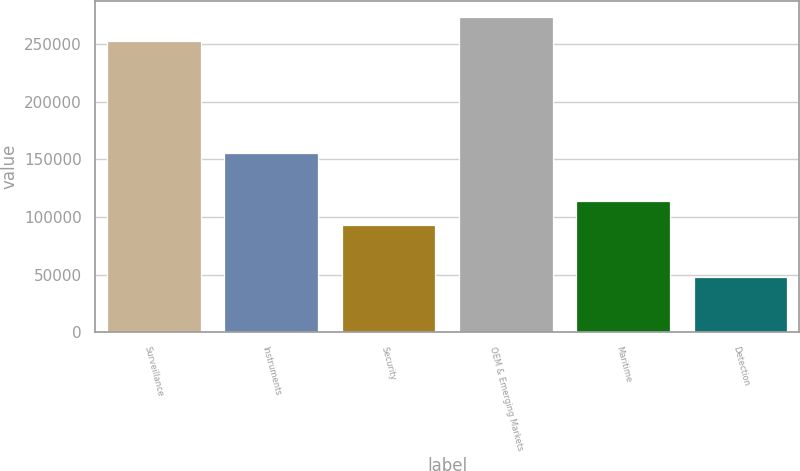Convert chart to OTSL. <chart><loc_0><loc_0><loc_500><loc_500><bar_chart><fcel>Surveillance<fcel>Instruments<fcel>Security<fcel>OEM & Emerging Markets<fcel>Maritime<fcel>Detection<nl><fcel>253341<fcel>155937<fcel>92719<fcel>274213<fcel>113591<fcel>48021<nl></chart> 